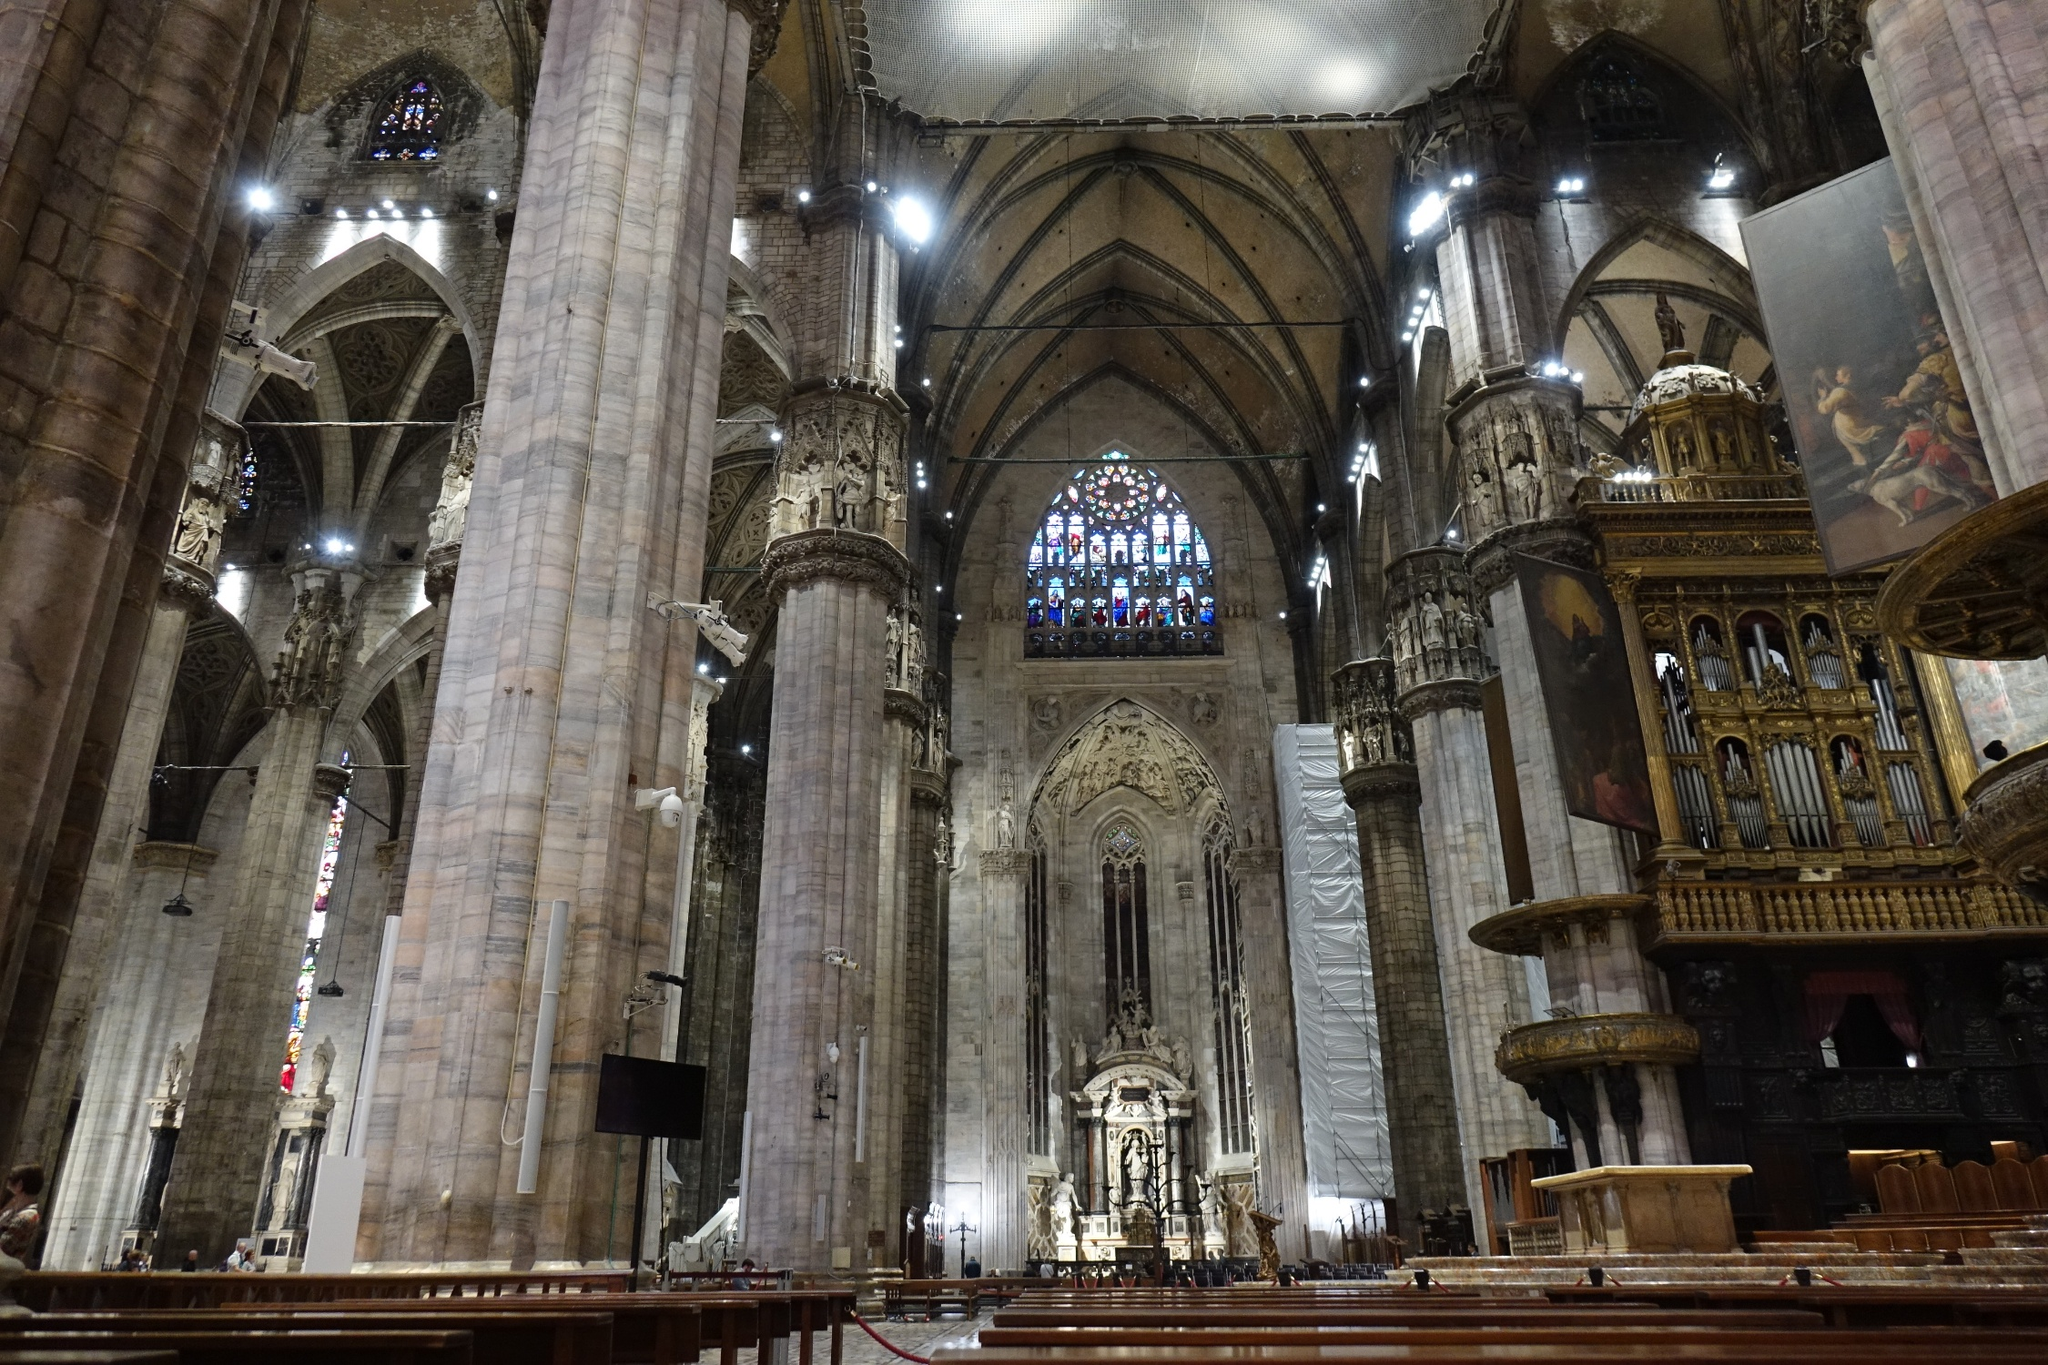Describe the visual elements that contribute to the sense of height and grandeur in this cathedral. The sense of height and grandeur in this cathedral is achieved through several visual elements. The towering marble columns, which are both massive in girth and height, draw the eyes upward with their sheer scale. The pointed arches, characteristic of Gothic architecture, further accentuate this vertical emphasis by guiding the gaze to the vaulted ceiling. This ceiling is an artwork in itself, with its intricate patterns and stained glass windows that filter vibrant light into the space, creating an aura of divinity and enormity. Additionally, the detailed carvings and statues that adorn the columns add to the awe-inspiring experience, making the viewer feel small in comparison to the monumental structure. How does the presence of scaffolding affect the visual impact of the cathedral? The presence of scaffolding, while temporary, adds a contrasting element to the visual impact of the cathedral. On one hand, it slightly detracts from the uninterrupted grandeur of the Gothic architecture, bringing a modern and mundane aspect into the historic and ornate space. However, on the other hand, it tells a story of preservation and continuous care. The scaffolding indicates that the cathedral is a living monument, regularly maintained and restored to preserve its beauty for future generations. This juxtaposition of old and new serves as a reminder of the cathedral's enduring legacy and the human effort required to sustain it. Imagine if the statues on the columns could tell stories. What kind of tales might they share from their vantage point inside the cathedral? If the statues on the columns could tell stories, they would share tales that span centuries. They might recount the countless ceremonies, from royal coronations to humble weddings, celebrated within the cathedral's walls. They could share the hushed prayers and the boisterous festivals, the moments of solitude and the gatherings of masses. The statues would speak of the craftsmanship and toil of the artisans who sculpted the marble, dedicating their lifework to something greater than themselves. They would tell stories of transformation, from the construction days to the times of renovation, witnessing the tides of history that passed through this sacred space. Above all, they would voice the timeless faith and devotion that have kept the cathedral alive through all these years. 